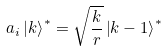<formula> <loc_0><loc_0><loc_500><loc_500>a _ { i } \left | k \right > ^ { * } = \sqrt { \frac { k } { r } } \left | k - 1 \right > ^ { * }</formula> 